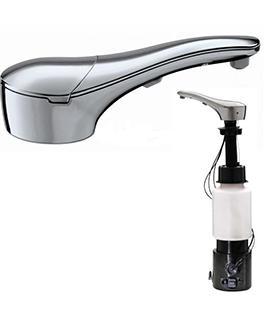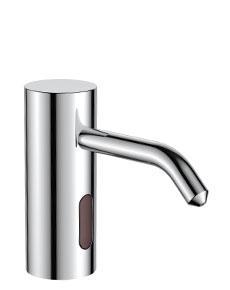The first image is the image on the left, the second image is the image on the right. Evaluate the accuracy of this statement regarding the images: "there is exactly one curved faucet in the image on the left". Is it true? Answer yes or no. No. The first image is the image on the left, the second image is the image on the right. Given the left and right images, does the statement "Right image includes one rounded sink with squirt-type dispenser nearby." hold true? Answer yes or no. No. 